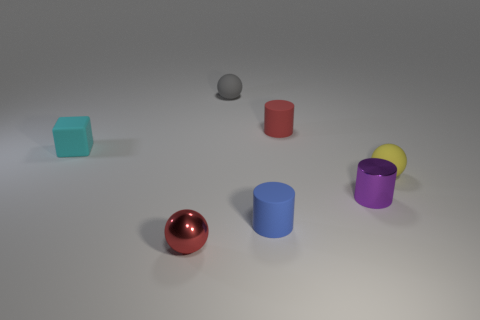What materials do the objects in the image seem to be made of, based on their appearance? Based on their appearances, the objects seem to be made of various materials with matte, shiny, and translucent surfaces, suggesting a mix of metallic and possibly plastic or ceramic attributes. 